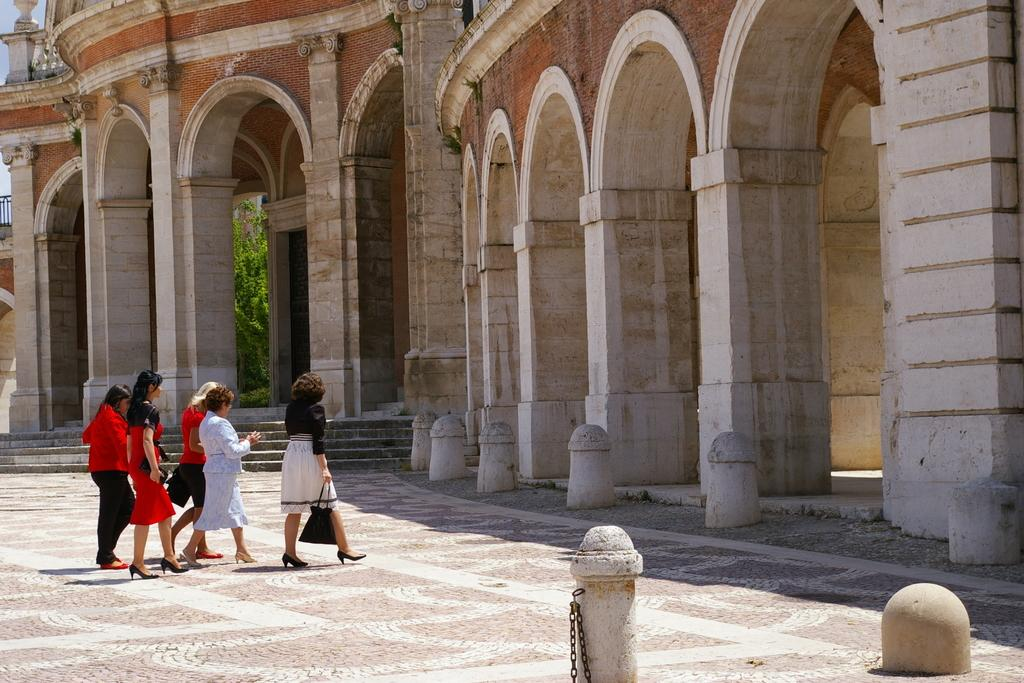What are the women in the image doing? The women in the image are walking. What can be seen in the image besides the women? There are barrier poles, a building, and creepers visible in the image. What is the condition of the sky in the image? The sky is visible in the image. Where is the office located in the image? There is no office present in the image. What type of tent can be seen in the image? There is no tent present in the image. 